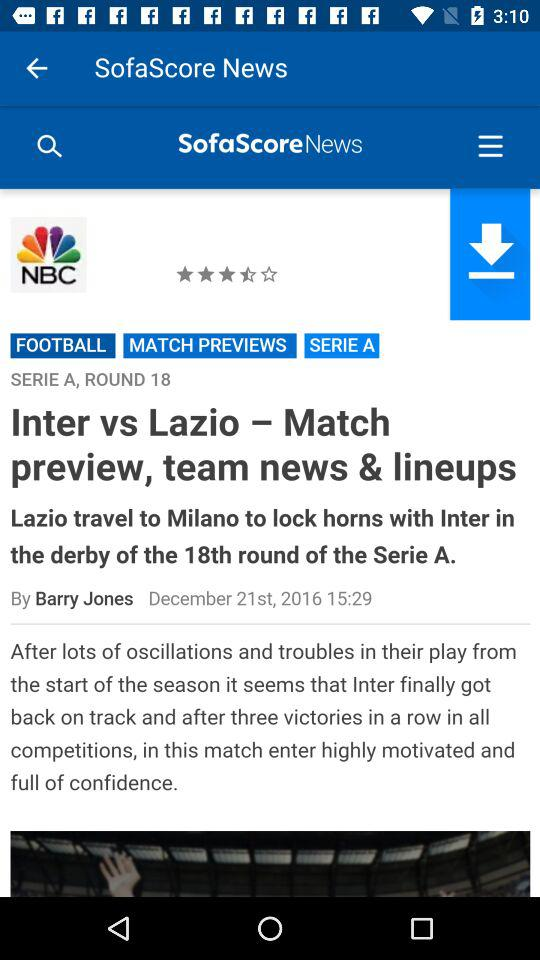On what date was the news published? The news was published on December 21st, 2016. 